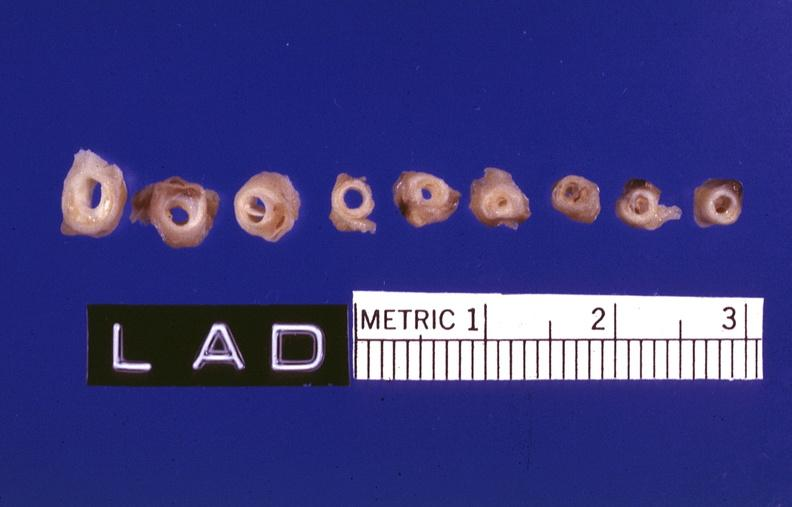where is this?
Answer the question using a single word or phrase. Vasculature 